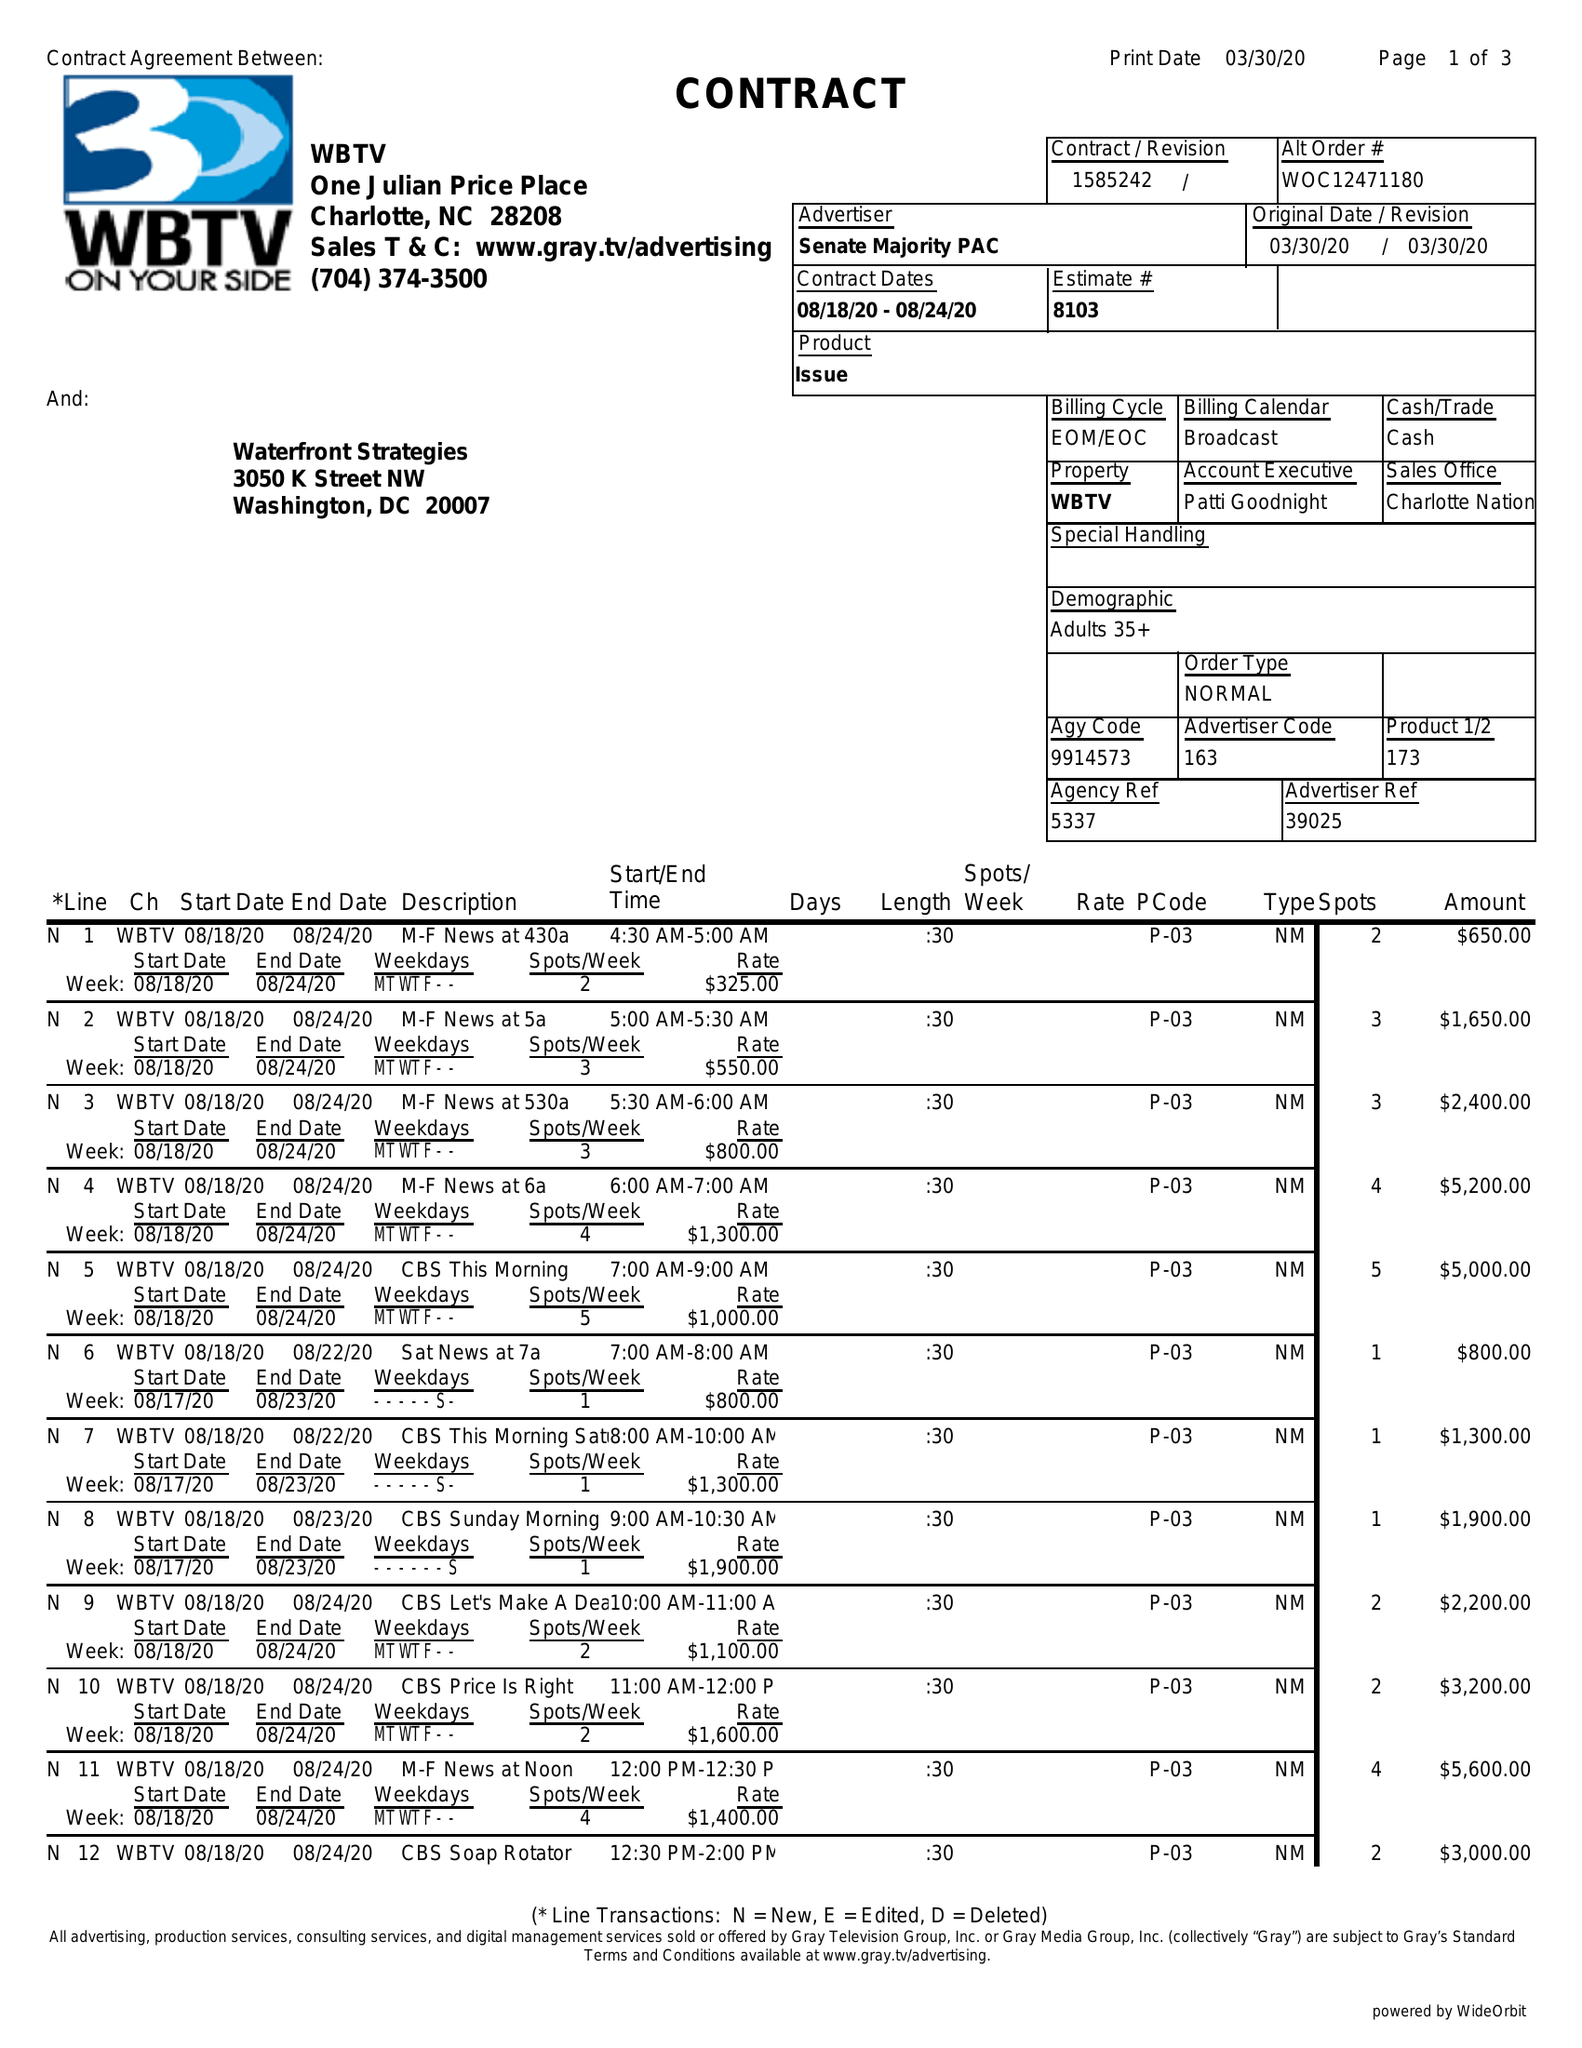What is the value for the gross_amount?
Answer the question using a single word or phrase. 88300.00 